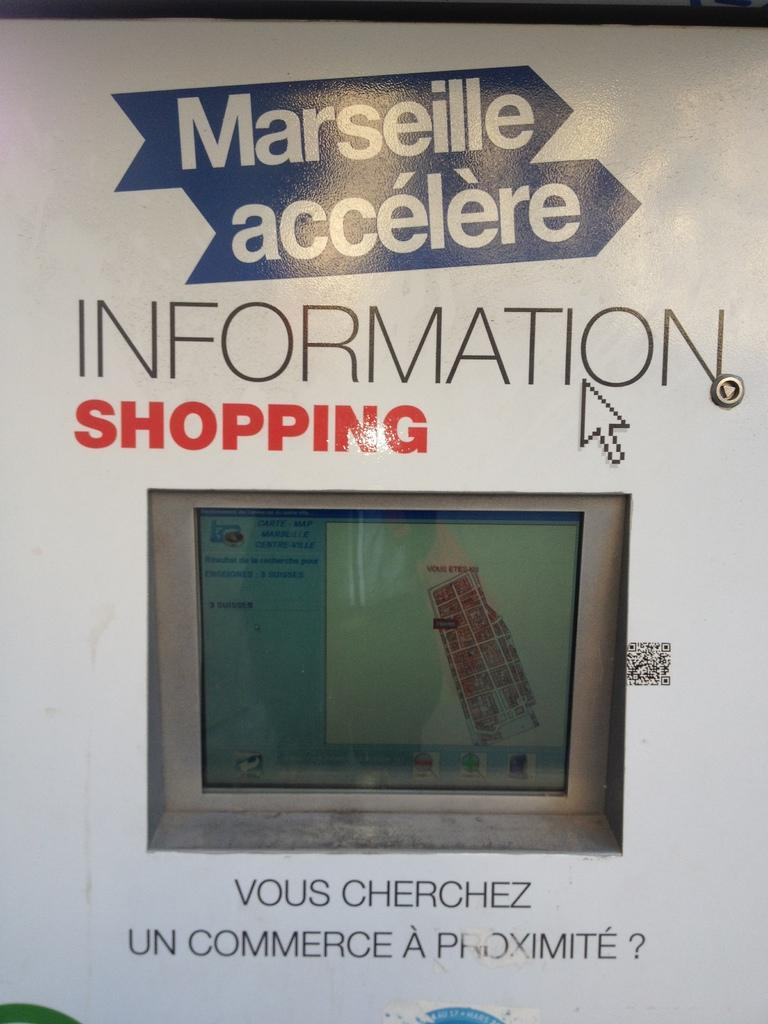Provide a one-sentence caption for the provided image. A gray and blue screen with a design shown on it and up top the words Information shopping. 